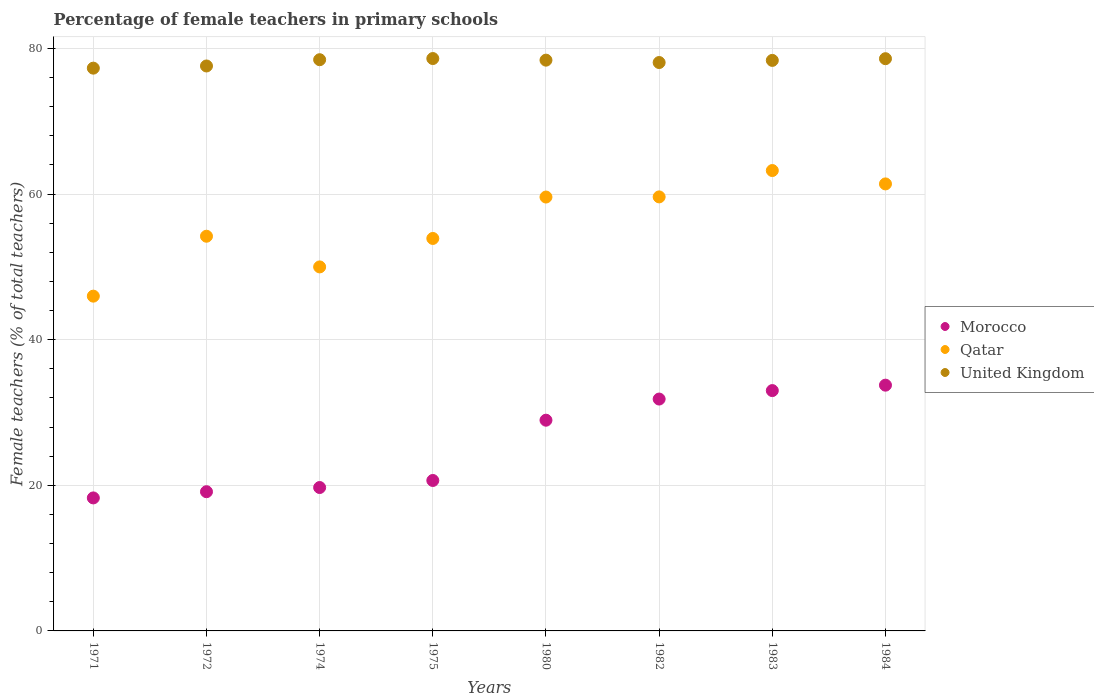How many different coloured dotlines are there?
Make the answer very short. 3. Is the number of dotlines equal to the number of legend labels?
Your answer should be compact. Yes. What is the percentage of female teachers in Qatar in 1984?
Your answer should be compact. 61.4. Across all years, what is the maximum percentage of female teachers in Morocco?
Offer a very short reply. 33.76. Across all years, what is the minimum percentage of female teachers in Morocco?
Ensure brevity in your answer.  18.27. In which year was the percentage of female teachers in Morocco maximum?
Offer a terse response. 1984. What is the total percentage of female teachers in Qatar in the graph?
Give a very brief answer. 447.96. What is the difference between the percentage of female teachers in Qatar in 1975 and that in 1984?
Provide a succinct answer. -7.49. What is the difference between the percentage of female teachers in Morocco in 1984 and the percentage of female teachers in Qatar in 1982?
Provide a succinct answer. -25.86. What is the average percentage of female teachers in Qatar per year?
Give a very brief answer. 56. In the year 1972, what is the difference between the percentage of female teachers in Qatar and percentage of female teachers in Morocco?
Your answer should be very brief. 35.09. What is the ratio of the percentage of female teachers in Qatar in 1974 to that in 1984?
Make the answer very short. 0.81. Is the percentage of female teachers in Qatar in 1975 less than that in 1984?
Make the answer very short. Yes. Is the difference between the percentage of female teachers in Qatar in 1971 and 1982 greater than the difference between the percentage of female teachers in Morocco in 1971 and 1982?
Your answer should be very brief. No. What is the difference between the highest and the second highest percentage of female teachers in Qatar?
Offer a very short reply. 1.84. What is the difference between the highest and the lowest percentage of female teachers in Morocco?
Make the answer very short. 15.49. Is it the case that in every year, the sum of the percentage of female teachers in Qatar and percentage of female teachers in United Kingdom  is greater than the percentage of female teachers in Morocco?
Your answer should be very brief. Yes. Is the percentage of female teachers in Qatar strictly greater than the percentage of female teachers in Morocco over the years?
Your answer should be compact. Yes. How many dotlines are there?
Provide a succinct answer. 3. What is the difference between two consecutive major ticks on the Y-axis?
Make the answer very short. 20. How many legend labels are there?
Provide a succinct answer. 3. How are the legend labels stacked?
Offer a terse response. Vertical. What is the title of the graph?
Make the answer very short. Percentage of female teachers in primary schools. Does "Tunisia" appear as one of the legend labels in the graph?
Keep it short and to the point. No. What is the label or title of the Y-axis?
Offer a very short reply. Female teachers (% of total teachers). What is the Female teachers (% of total teachers) in Morocco in 1971?
Ensure brevity in your answer.  18.27. What is the Female teachers (% of total teachers) in Qatar in 1971?
Provide a short and direct response. 45.98. What is the Female teachers (% of total teachers) of United Kingdom in 1971?
Provide a succinct answer. 77.3. What is the Female teachers (% of total teachers) of Morocco in 1972?
Your answer should be compact. 19.12. What is the Female teachers (% of total teachers) of Qatar in 1972?
Make the answer very short. 54.21. What is the Female teachers (% of total teachers) of United Kingdom in 1972?
Keep it short and to the point. 77.6. What is the Female teachers (% of total teachers) of Morocco in 1974?
Offer a very short reply. 19.7. What is the Female teachers (% of total teachers) in Qatar in 1974?
Your answer should be compact. 50. What is the Female teachers (% of total teachers) of United Kingdom in 1974?
Provide a succinct answer. 78.46. What is the Female teachers (% of total teachers) of Morocco in 1975?
Offer a very short reply. 20.66. What is the Female teachers (% of total teachers) of Qatar in 1975?
Provide a succinct answer. 53.91. What is the Female teachers (% of total teachers) in United Kingdom in 1975?
Provide a short and direct response. 78.62. What is the Female teachers (% of total teachers) in Morocco in 1980?
Give a very brief answer. 28.95. What is the Female teachers (% of total teachers) in Qatar in 1980?
Provide a succinct answer. 59.6. What is the Female teachers (% of total teachers) of United Kingdom in 1980?
Ensure brevity in your answer.  78.4. What is the Female teachers (% of total teachers) in Morocco in 1982?
Your response must be concise. 31.85. What is the Female teachers (% of total teachers) in Qatar in 1982?
Your response must be concise. 59.62. What is the Female teachers (% of total teachers) of United Kingdom in 1982?
Ensure brevity in your answer.  78.07. What is the Female teachers (% of total teachers) in Morocco in 1983?
Your answer should be compact. 33.01. What is the Female teachers (% of total teachers) in Qatar in 1983?
Your answer should be very brief. 63.24. What is the Female teachers (% of total teachers) of United Kingdom in 1983?
Offer a very short reply. 78.37. What is the Female teachers (% of total teachers) in Morocco in 1984?
Your answer should be very brief. 33.76. What is the Female teachers (% of total teachers) of Qatar in 1984?
Ensure brevity in your answer.  61.4. What is the Female teachers (% of total teachers) in United Kingdom in 1984?
Provide a short and direct response. 78.6. Across all years, what is the maximum Female teachers (% of total teachers) in Morocco?
Provide a succinct answer. 33.76. Across all years, what is the maximum Female teachers (% of total teachers) of Qatar?
Offer a terse response. 63.24. Across all years, what is the maximum Female teachers (% of total teachers) in United Kingdom?
Your answer should be compact. 78.62. Across all years, what is the minimum Female teachers (% of total teachers) in Morocco?
Your answer should be compact. 18.27. Across all years, what is the minimum Female teachers (% of total teachers) of Qatar?
Give a very brief answer. 45.98. Across all years, what is the minimum Female teachers (% of total teachers) in United Kingdom?
Offer a terse response. 77.3. What is the total Female teachers (% of total teachers) in Morocco in the graph?
Offer a very short reply. 205.31. What is the total Female teachers (% of total teachers) of Qatar in the graph?
Your answer should be compact. 447.96. What is the total Female teachers (% of total teachers) of United Kingdom in the graph?
Keep it short and to the point. 625.43. What is the difference between the Female teachers (% of total teachers) of Morocco in 1971 and that in 1972?
Give a very brief answer. -0.85. What is the difference between the Female teachers (% of total teachers) of Qatar in 1971 and that in 1972?
Your answer should be very brief. -8.23. What is the difference between the Female teachers (% of total teachers) in United Kingdom in 1971 and that in 1972?
Offer a very short reply. -0.3. What is the difference between the Female teachers (% of total teachers) of Morocco in 1971 and that in 1974?
Provide a short and direct response. -1.43. What is the difference between the Female teachers (% of total teachers) in Qatar in 1971 and that in 1974?
Ensure brevity in your answer.  -4.02. What is the difference between the Female teachers (% of total teachers) in United Kingdom in 1971 and that in 1974?
Provide a succinct answer. -1.16. What is the difference between the Female teachers (% of total teachers) of Morocco in 1971 and that in 1975?
Make the answer very short. -2.4. What is the difference between the Female teachers (% of total teachers) of Qatar in 1971 and that in 1975?
Give a very brief answer. -7.92. What is the difference between the Female teachers (% of total teachers) of United Kingdom in 1971 and that in 1975?
Your response must be concise. -1.32. What is the difference between the Female teachers (% of total teachers) of Morocco in 1971 and that in 1980?
Make the answer very short. -10.68. What is the difference between the Female teachers (% of total teachers) of Qatar in 1971 and that in 1980?
Offer a very short reply. -13.61. What is the difference between the Female teachers (% of total teachers) in United Kingdom in 1971 and that in 1980?
Your response must be concise. -1.1. What is the difference between the Female teachers (% of total teachers) of Morocco in 1971 and that in 1982?
Offer a very short reply. -13.58. What is the difference between the Female teachers (% of total teachers) of Qatar in 1971 and that in 1982?
Your answer should be compact. -13.63. What is the difference between the Female teachers (% of total teachers) of United Kingdom in 1971 and that in 1982?
Keep it short and to the point. -0.77. What is the difference between the Female teachers (% of total teachers) in Morocco in 1971 and that in 1983?
Your answer should be compact. -14.74. What is the difference between the Female teachers (% of total teachers) in Qatar in 1971 and that in 1983?
Give a very brief answer. -17.25. What is the difference between the Female teachers (% of total teachers) of United Kingdom in 1971 and that in 1983?
Give a very brief answer. -1.07. What is the difference between the Female teachers (% of total teachers) of Morocco in 1971 and that in 1984?
Provide a short and direct response. -15.49. What is the difference between the Female teachers (% of total teachers) of Qatar in 1971 and that in 1984?
Your response must be concise. -15.42. What is the difference between the Female teachers (% of total teachers) in United Kingdom in 1971 and that in 1984?
Your response must be concise. -1.3. What is the difference between the Female teachers (% of total teachers) in Morocco in 1972 and that in 1974?
Your answer should be very brief. -0.58. What is the difference between the Female teachers (% of total teachers) of Qatar in 1972 and that in 1974?
Make the answer very short. 4.21. What is the difference between the Female teachers (% of total teachers) of United Kingdom in 1972 and that in 1974?
Offer a very short reply. -0.86. What is the difference between the Female teachers (% of total teachers) of Morocco in 1972 and that in 1975?
Your answer should be very brief. -1.54. What is the difference between the Female teachers (% of total teachers) of Qatar in 1972 and that in 1975?
Your answer should be very brief. 0.3. What is the difference between the Female teachers (% of total teachers) in United Kingdom in 1972 and that in 1975?
Make the answer very short. -1.02. What is the difference between the Female teachers (% of total teachers) of Morocco in 1972 and that in 1980?
Make the answer very short. -9.82. What is the difference between the Female teachers (% of total teachers) in Qatar in 1972 and that in 1980?
Keep it short and to the point. -5.38. What is the difference between the Female teachers (% of total teachers) of United Kingdom in 1972 and that in 1980?
Ensure brevity in your answer.  -0.8. What is the difference between the Female teachers (% of total teachers) of Morocco in 1972 and that in 1982?
Offer a very short reply. -12.73. What is the difference between the Female teachers (% of total teachers) of Qatar in 1972 and that in 1982?
Give a very brief answer. -5.4. What is the difference between the Female teachers (% of total teachers) in United Kingdom in 1972 and that in 1982?
Give a very brief answer. -0.47. What is the difference between the Female teachers (% of total teachers) in Morocco in 1972 and that in 1983?
Ensure brevity in your answer.  -13.89. What is the difference between the Female teachers (% of total teachers) of Qatar in 1972 and that in 1983?
Provide a short and direct response. -9.02. What is the difference between the Female teachers (% of total teachers) of United Kingdom in 1972 and that in 1983?
Your answer should be very brief. -0.77. What is the difference between the Female teachers (% of total teachers) of Morocco in 1972 and that in 1984?
Ensure brevity in your answer.  -14.64. What is the difference between the Female teachers (% of total teachers) of Qatar in 1972 and that in 1984?
Offer a very short reply. -7.19. What is the difference between the Female teachers (% of total teachers) in United Kingdom in 1972 and that in 1984?
Provide a short and direct response. -1. What is the difference between the Female teachers (% of total teachers) in Morocco in 1974 and that in 1975?
Your response must be concise. -0.97. What is the difference between the Female teachers (% of total teachers) in Qatar in 1974 and that in 1975?
Offer a terse response. -3.91. What is the difference between the Female teachers (% of total teachers) in United Kingdom in 1974 and that in 1975?
Your answer should be very brief. -0.16. What is the difference between the Female teachers (% of total teachers) of Morocco in 1974 and that in 1980?
Offer a very short reply. -9.25. What is the difference between the Female teachers (% of total teachers) of Qatar in 1974 and that in 1980?
Provide a succinct answer. -9.6. What is the difference between the Female teachers (% of total teachers) of United Kingdom in 1974 and that in 1980?
Your answer should be compact. 0.06. What is the difference between the Female teachers (% of total teachers) in Morocco in 1974 and that in 1982?
Provide a short and direct response. -12.15. What is the difference between the Female teachers (% of total teachers) of Qatar in 1974 and that in 1982?
Offer a very short reply. -9.62. What is the difference between the Female teachers (% of total teachers) of United Kingdom in 1974 and that in 1982?
Offer a very short reply. 0.39. What is the difference between the Female teachers (% of total teachers) in Morocco in 1974 and that in 1983?
Offer a very short reply. -13.31. What is the difference between the Female teachers (% of total teachers) of Qatar in 1974 and that in 1983?
Offer a terse response. -13.24. What is the difference between the Female teachers (% of total teachers) of United Kingdom in 1974 and that in 1983?
Your answer should be very brief. 0.09. What is the difference between the Female teachers (% of total teachers) of Morocco in 1974 and that in 1984?
Offer a terse response. -14.06. What is the difference between the Female teachers (% of total teachers) of Qatar in 1974 and that in 1984?
Ensure brevity in your answer.  -11.4. What is the difference between the Female teachers (% of total teachers) of United Kingdom in 1974 and that in 1984?
Offer a very short reply. -0.14. What is the difference between the Female teachers (% of total teachers) of Morocco in 1975 and that in 1980?
Provide a short and direct response. -8.28. What is the difference between the Female teachers (% of total teachers) of Qatar in 1975 and that in 1980?
Offer a terse response. -5.69. What is the difference between the Female teachers (% of total teachers) of United Kingdom in 1975 and that in 1980?
Keep it short and to the point. 0.22. What is the difference between the Female teachers (% of total teachers) of Morocco in 1975 and that in 1982?
Keep it short and to the point. -11.18. What is the difference between the Female teachers (% of total teachers) of Qatar in 1975 and that in 1982?
Provide a short and direct response. -5.71. What is the difference between the Female teachers (% of total teachers) of United Kingdom in 1975 and that in 1982?
Your response must be concise. 0.55. What is the difference between the Female teachers (% of total teachers) of Morocco in 1975 and that in 1983?
Ensure brevity in your answer.  -12.35. What is the difference between the Female teachers (% of total teachers) in Qatar in 1975 and that in 1983?
Offer a very short reply. -9.33. What is the difference between the Female teachers (% of total teachers) in United Kingdom in 1975 and that in 1983?
Your answer should be compact. 0.25. What is the difference between the Female teachers (% of total teachers) of Morocco in 1975 and that in 1984?
Make the answer very short. -13.09. What is the difference between the Female teachers (% of total teachers) in Qatar in 1975 and that in 1984?
Offer a terse response. -7.49. What is the difference between the Female teachers (% of total teachers) in United Kingdom in 1975 and that in 1984?
Provide a succinct answer. 0.02. What is the difference between the Female teachers (% of total teachers) of Morocco in 1980 and that in 1982?
Make the answer very short. -2.9. What is the difference between the Female teachers (% of total teachers) of Qatar in 1980 and that in 1982?
Give a very brief answer. -0.02. What is the difference between the Female teachers (% of total teachers) in United Kingdom in 1980 and that in 1982?
Provide a succinct answer. 0.33. What is the difference between the Female teachers (% of total teachers) of Morocco in 1980 and that in 1983?
Offer a very short reply. -4.07. What is the difference between the Female teachers (% of total teachers) of Qatar in 1980 and that in 1983?
Provide a short and direct response. -3.64. What is the difference between the Female teachers (% of total teachers) in United Kingdom in 1980 and that in 1983?
Your response must be concise. 0.03. What is the difference between the Female teachers (% of total teachers) of Morocco in 1980 and that in 1984?
Provide a succinct answer. -4.81. What is the difference between the Female teachers (% of total teachers) in Qatar in 1980 and that in 1984?
Make the answer very short. -1.8. What is the difference between the Female teachers (% of total teachers) of United Kingdom in 1980 and that in 1984?
Ensure brevity in your answer.  -0.2. What is the difference between the Female teachers (% of total teachers) in Morocco in 1982 and that in 1983?
Make the answer very short. -1.16. What is the difference between the Female teachers (% of total teachers) in Qatar in 1982 and that in 1983?
Offer a terse response. -3.62. What is the difference between the Female teachers (% of total teachers) in United Kingdom in 1982 and that in 1983?
Your answer should be compact. -0.29. What is the difference between the Female teachers (% of total teachers) in Morocco in 1982 and that in 1984?
Your response must be concise. -1.91. What is the difference between the Female teachers (% of total teachers) of Qatar in 1982 and that in 1984?
Give a very brief answer. -1.78. What is the difference between the Female teachers (% of total teachers) in United Kingdom in 1982 and that in 1984?
Give a very brief answer. -0.53. What is the difference between the Female teachers (% of total teachers) in Morocco in 1983 and that in 1984?
Ensure brevity in your answer.  -0.74. What is the difference between the Female teachers (% of total teachers) of Qatar in 1983 and that in 1984?
Offer a very short reply. 1.84. What is the difference between the Female teachers (% of total teachers) in United Kingdom in 1983 and that in 1984?
Provide a succinct answer. -0.23. What is the difference between the Female teachers (% of total teachers) of Morocco in 1971 and the Female teachers (% of total teachers) of Qatar in 1972?
Keep it short and to the point. -35.95. What is the difference between the Female teachers (% of total teachers) in Morocco in 1971 and the Female teachers (% of total teachers) in United Kingdom in 1972?
Your answer should be compact. -59.33. What is the difference between the Female teachers (% of total teachers) in Qatar in 1971 and the Female teachers (% of total teachers) in United Kingdom in 1972?
Offer a terse response. -31.62. What is the difference between the Female teachers (% of total teachers) of Morocco in 1971 and the Female teachers (% of total teachers) of Qatar in 1974?
Provide a succinct answer. -31.73. What is the difference between the Female teachers (% of total teachers) of Morocco in 1971 and the Female teachers (% of total teachers) of United Kingdom in 1974?
Your response must be concise. -60.19. What is the difference between the Female teachers (% of total teachers) of Qatar in 1971 and the Female teachers (% of total teachers) of United Kingdom in 1974?
Keep it short and to the point. -32.48. What is the difference between the Female teachers (% of total teachers) of Morocco in 1971 and the Female teachers (% of total teachers) of Qatar in 1975?
Keep it short and to the point. -35.64. What is the difference between the Female teachers (% of total teachers) in Morocco in 1971 and the Female teachers (% of total teachers) in United Kingdom in 1975?
Offer a very short reply. -60.35. What is the difference between the Female teachers (% of total teachers) in Qatar in 1971 and the Female teachers (% of total teachers) in United Kingdom in 1975?
Provide a succinct answer. -32.64. What is the difference between the Female teachers (% of total teachers) of Morocco in 1971 and the Female teachers (% of total teachers) of Qatar in 1980?
Offer a very short reply. -41.33. What is the difference between the Female teachers (% of total teachers) in Morocco in 1971 and the Female teachers (% of total teachers) in United Kingdom in 1980?
Provide a short and direct response. -60.13. What is the difference between the Female teachers (% of total teachers) in Qatar in 1971 and the Female teachers (% of total teachers) in United Kingdom in 1980?
Your answer should be very brief. -32.42. What is the difference between the Female teachers (% of total teachers) in Morocco in 1971 and the Female teachers (% of total teachers) in Qatar in 1982?
Provide a succinct answer. -41.35. What is the difference between the Female teachers (% of total teachers) of Morocco in 1971 and the Female teachers (% of total teachers) of United Kingdom in 1982?
Ensure brevity in your answer.  -59.81. What is the difference between the Female teachers (% of total teachers) of Qatar in 1971 and the Female teachers (% of total teachers) of United Kingdom in 1982?
Ensure brevity in your answer.  -32.09. What is the difference between the Female teachers (% of total teachers) of Morocco in 1971 and the Female teachers (% of total teachers) of Qatar in 1983?
Your response must be concise. -44.97. What is the difference between the Female teachers (% of total teachers) in Morocco in 1971 and the Female teachers (% of total teachers) in United Kingdom in 1983?
Your answer should be compact. -60.1. What is the difference between the Female teachers (% of total teachers) of Qatar in 1971 and the Female teachers (% of total teachers) of United Kingdom in 1983?
Offer a very short reply. -32.38. What is the difference between the Female teachers (% of total teachers) of Morocco in 1971 and the Female teachers (% of total teachers) of Qatar in 1984?
Make the answer very short. -43.13. What is the difference between the Female teachers (% of total teachers) in Morocco in 1971 and the Female teachers (% of total teachers) in United Kingdom in 1984?
Your response must be concise. -60.33. What is the difference between the Female teachers (% of total teachers) of Qatar in 1971 and the Female teachers (% of total teachers) of United Kingdom in 1984?
Provide a succinct answer. -32.62. What is the difference between the Female teachers (% of total teachers) in Morocco in 1972 and the Female teachers (% of total teachers) in Qatar in 1974?
Your answer should be very brief. -30.88. What is the difference between the Female teachers (% of total teachers) of Morocco in 1972 and the Female teachers (% of total teachers) of United Kingdom in 1974?
Offer a very short reply. -59.34. What is the difference between the Female teachers (% of total teachers) of Qatar in 1972 and the Female teachers (% of total teachers) of United Kingdom in 1974?
Provide a short and direct response. -24.25. What is the difference between the Female teachers (% of total teachers) in Morocco in 1972 and the Female teachers (% of total teachers) in Qatar in 1975?
Make the answer very short. -34.79. What is the difference between the Female teachers (% of total teachers) in Morocco in 1972 and the Female teachers (% of total teachers) in United Kingdom in 1975?
Give a very brief answer. -59.5. What is the difference between the Female teachers (% of total teachers) in Qatar in 1972 and the Female teachers (% of total teachers) in United Kingdom in 1975?
Offer a very short reply. -24.41. What is the difference between the Female teachers (% of total teachers) in Morocco in 1972 and the Female teachers (% of total teachers) in Qatar in 1980?
Your answer should be very brief. -40.48. What is the difference between the Female teachers (% of total teachers) of Morocco in 1972 and the Female teachers (% of total teachers) of United Kingdom in 1980?
Provide a short and direct response. -59.28. What is the difference between the Female teachers (% of total teachers) in Qatar in 1972 and the Female teachers (% of total teachers) in United Kingdom in 1980?
Make the answer very short. -24.19. What is the difference between the Female teachers (% of total teachers) of Morocco in 1972 and the Female teachers (% of total teachers) of Qatar in 1982?
Keep it short and to the point. -40.5. What is the difference between the Female teachers (% of total teachers) of Morocco in 1972 and the Female teachers (% of total teachers) of United Kingdom in 1982?
Make the answer very short. -58.95. What is the difference between the Female teachers (% of total teachers) in Qatar in 1972 and the Female teachers (% of total teachers) in United Kingdom in 1982?
Make the answer very short. -23.86. What is the difference between the Female teachers (% of total teachers) in Morocco in 1972 and the Female teachers (% of total teachers) in Qatar in 1983?
Your answer should be very brief. -44.12. What is the difference between the Female teachers (% of total teachers) of Morocco in 1972 and the Female teachers (% of total teachers) of United Kingdom in 1983?
Your answer should be very brief. -59.25. What is the difference between the Female teachers (% of total teachers) in Qatar in 1972 and the Female teachers (% of total teachers) in United Kingdom in 1983?
Your response must be concise. -24.15. What is the difference between the Female teachers (% of total teachers) in Morocco in 1972 and the Female teachers (% of total teachers) in Qatar in 1984?
Your answer should be very brief. -42.28. What is the difference between the Female teachers (% of total teachers) of Morocco in 1972 and the Female teachers (% of total teachers) of United Kingdom in 1984?
Offer a very short reply. -59.48. What is the difference between the Female teachers (% of total teachers) of Qatar in 1972 and the Female teachers (% of total teachers) of United Kingdom in 1984?
Provide a short and direct response. -24.39. What is the difference between the Female teachers (% of total teachers) in Morocco in 1974 and the Female teachers (% of total teachers) in Qatar in 1975?
Your answer should be very brief. -34.21. What is the difference between the Female teachers (% of total teachers) of Morocco in 1974 and the Female teachers (% of total teachers) of United Kingdom in 1975?
Keep it short and to the point. -58.92. What is the difference between the Female teachers (% of total teachers) of Qatar in 1974 and the Female teachers (% of total teachers) of United Kingdom in 1975?
Offer a very short reply. -28.62. What is the difference between the Female teachers (% of total teachers) of Morocco in 1974 and the Female teachers (% of total teachers) of Qatar in 1980?
Your answer should be compact. -39.9. What is the difference between the Female teachers (% of total teachers) of Morocco in 1974 and the Female teachers (% of total teachers) of United Kingdom in 1980?
Your answer should be very brief. -58.7. What is the difference between the Female teachers (% of total teachers) of Qatar in 1974 and the Female teachers (% of total teachers) of United Kingdom in 1980?
Give a very brief answer. -28.4. What is the difference between the Female teachers (% of total teachers) of Morocco in 1974 and the Female teachers (% of total teachers) of Qatar in 1982?
Keep it short and to the point. -39.92. What is the difference between the Female teachers (% of total teachers) of Morocco in 1974 and the Female teachers (% of total teachers) of United Kingdom in 1982?
Offer a terse response. -58.38. What is the difference between the Female teachers (% of total teachers) in Qatar in 1974 and the Female teachers (% of total teachers) in United Kingdom in 1982?
Provide a succinct answer. -28.07. What is the difference between the Female teachers (% of total teachers) of Morocco in 1974 and the Female teachers (% of total teachers) of Qatar in 1983?
Your answer should be very brief. -43.54. What is the difference between the Female teachers (% of total teachers) in Morocco in 1974 and the Female teachers (% of total teachers) in United Kingdom in 1983?
Make the answer very short. -58.67. What is the difference between the Female teachers (% of total teachers) of Qatar in 1974 and the Female teachers (% of total teachers) of United Kingdom in 1983?
Keep it short and to the point. -28.37. What is the difference between the Female teachers (% of total teachers) of Morocco in 1974 and the Female teachers (% of total teachers) of Qatar in 1984?
Keep it short and to the point. -41.7. What is the difference between the Female teachers (% of total teachers) of Morocco in 1974 and the Female teachers (% of total teachers) of United Kingdom in 1984?
Give a very brief answer. -58.9. What is the difference between the Female teachers (% of total teachers) in Qatar in 1974 and the Female teachers (% of total teachers) in United Kingdom in 1984?
Provide a short and direct response. -28.6. What is the difference between the Female teachers (% of total teachers) in Morocco in 1975 and the Female teachers (% of total teachers) in Qatar in 1980?
Provide a succinct answer. -38.93. What is the difference between the Female teachers (% of total teachers) of Morocco in 1975 and the Female teachers (% of total teachers) of United Kingdom in 1980?
Your response must be concise. -57.74. What is the difference between the Female teachers (% of total teachers) of Qatar in 1975 and the Female teachers (% of total teachers) of United Kingdom in 1980?
Provide a short and direct response. -24.49. What is the difference between the Female teachers (% of total teachers) in Morocco in 1975 and the Female teachers (% of total teachers) in Qatar in 1982?
Keep it short and to the point. -38.95. What is the difference between the Female teachers (% of total teachers) in Morocco in 1975 and the Female teachers (% of total teachers) in United Kingdom in 1982?
Your response must be concise. -57.41. What is the difference between the Female teachers (% of total teachers) in Qatar in 1975 and the Female teachers (% of total teachers) in United Kingdom in 1982?
Ensure brevity in your answer.  -24.17. What is the difference between the Female teachers (% of total teachers) of Morocco in 1975 and the Female teachers (% of total teachers) of Qatar in 1983?
Give a very brief answer. -42.57. What is the difference between the Female teachers (% of total teachers) of Morocco in 1975 and the Female teachers (% of total teachers) of United Kingdom in 1983?
Ensure brevity in your answer.  -57.7. What is the difference between the Female teachers (% of total teachers) of Qatar in 1975 and the Female teachers (% of total teachers) of United Kingdom in 1983?
Provide a succinct answer. -24.46. What is the difference between the Female teachers (% of total teachers) of Morocco in 1975 and the Female teachers (% of total teachers) of Qatar in 1984?
Provide a short and direct response. -40.74. What is the difference between the Female teachers (% of total teachers) of Morocco in 1975 and the Female teachers (% of total teachers) of United Kingdom in 1984?
Ensure brevity in your answer.  -57.94. What is the difference between the Female teachers (% of total teachers) in Qatar in 1975 and the Female teachers (% of total teachers) in United Kingdom in 1984?
Your response must be concise. -24.69. What is the difference between the Female teachers (% of total teachers) of Morocco in 1980 and the Female teachers (% of total teachers) of Qatar in 1982?
Give a very brief answer. -30.67. What is the difference between the Female teachers (% of total teachers) of Morocco in 1980 and the Female teachers (% of total teachers) of United Kingdom in 1982?
Your answer should be very brief. -49.13. What is the difference between the Female teachers (% of total teachers) in Qatar in 1980 and the Female teachers (% of total teachers) in United Kingdom in 1982?
Ensure brevity in your answer.  -18.48. What is the difference between the Female teachers (% of total teachers) of Morocco in 1980 and the Female teachers (% of total teachers) of Qatar in 1983?
Offer a terse response. -34.29. What is the difference between the Female teachers (% of total teachers) of Morocco in 1980 and the Female teachers (% of total teachers) of United Kingdom in 1983?
Provide a short and direct response. -49.42. What is the difference between the Female teachers (% of total teachers) in Qatar in 1980 and the Female teachers (% of total teachers) in United Kingdom in 1983?
Offer a terse response. -18.77. What is the difference between the Female teachers (% of total teachers) in Morocco in 1980 and the Female teachers (% of total teachers) in Qatar in 1984?
Provide a short and direct response. -32.46. What is the difference between the Female teachers (% of total teachers) of Morocco in 1980 and the Female teachers (% of total teachers) of United Kingdom in 1984?
Offer a terse response. -49.66. What is the difference between the Female teachers (% of total teachers) of Qatar in 1980 and the Female teachers (% of total teachers) of United Kingdom in 1984?
Your answer should be very brief. -19. What is the difference between the Female teachers (% of total teachers) in Morocco in 1982 and the Female teachers (% of total teachers) in Qatar in 1983?
Keep it short and to the point. -31.39. What is the difference between the Female teachers (% of total teachers) in Morocco in 1982 and the Female teachers (% of total teachers) in United Kingdom in 1983?
Ensure brevity in your answer.  -46.52. What is the difference between the Female teachers (% of total teachers) of Qatar in 1982 and the Female teachers (% of total teachers) of United Kingdom in 1983?
Your response must be concise. -18.75. What is the difference between the Female teachers (% of total teachers) of Morocco in 1982 and the Female teachers (% of total teachers) of Qatar in 1984?
Your answer should be compact. -29.55. What is the difference between the Female teachers (% of total teachers) of Morocco in 1982 and the Female teachers (% of total teachers) of United Kingdom in 1984?
Offer a terse response. -46.75. What is the difference between the Female teachers (% of total teachers) of Qatar in 1982 and the Female teachers (% of total teachers) of United Kingdom in 1984?
Provide a short and direct response. -18.98. What is the difference between the Female teachers (% of total teachers) in Morocco in 1983 and the Female teachers (% of total teachers) in Qatar in 1984?
Keep it short and to the point. -28.39. What is the difference between the Female teachers (% of total teachers) in Morocco in 1983 and the Female teachers (% of total teachers) in United Kingdom in 1984?
Your answer should be compact. -45.59. What is the difference between the Female teachers (% of total teachers) in Qatar in 1983 and the Female teachers (% of total teachers) in United Kingdom in 1984?
Keep it short and to the point. -15.36. What is the average Female teachers (% of total teachers) in Morocco per year?
Keep it short and to the point. 25.66. What is the average Female teachers (% of total teachers) in Qatar per year?
Keep it short and to the point. 56. What is the average Female teachers (% of total teachers) in United Kingdom per year?
Provide a succinct answer. 78.18. In the year 1971, what is the difference between the Female teachers (% of total teachers) in Morocco and Female teachers (% of total teachers) in Qatar?
Your answer should be very brief. -27.72. In the year 1971, what is the difference between the Female teachers (% of total teachers) of Morocco and Female teachers (% of total teachers) of United Kingdom?
Provide a succinct answer. -59.03. In the year 1971, what is the difference between the Female teachers (% of total teachers) in Qatar and Female teachers (% of total teachers) in United Kingdom?
Offer a very short reply. -31.32. In the year 1972, what is the difference between the Female teachers (% of total teachers) in Morocco and Female teachers (% of total teachers) in Qatar?
Give a very brief answer. -35.09. In the year 1972, what is the difference between the Female teachers (% of total teachers) in Morocco and Female teachers (% of total teachers) in United Kingdom?
Provide a short and direct response. -58.48. In the year 1972, what is the difference between the Female teachers (% of total teachers) of Qatar and Female teachers (% of total teachers) of United Kingdom?
Your answer should be compact. -23.39. In the year 1974, what is the difference between the Female teachers (% of total teachers) in Morocco and Female teachers (% of total teachers) in Qatar?
Offer a very short reply. -30.3. In the year 1974, what is the difference between the Female teachers (% of total teachers) in Morocco and Female teachers (% of total teachers) in United Kingdom?
Your answer should be very brief. -58.76. In the year 1974, what is the difference between the Female teachers (% of total teachers) of Qatar and Female teachers (% of total teachers) of United Kingdom?
Your answer should be compact. -28.46. In the year 1975, what is the difference between the Female teachers (% of total teachers) of Morocco and Female teachers (% of total teachers) of Qatar?
Offer a very short reply. -33.24. In the year 1975, what is the difference between the Female teachers (% of total teachers) in Morocco and Female teachers (% of total teachers) in United Kingdom?
Your answer should be very brief. -57.96. In the year 1975, what is the difference between the Female teachers (% of total teachers) in Qatar and Female teachers (% of total teachers) in United Kingdom?
Offer a terse response. -24.71. In the year 1980, what is the difference between the Female teachers (% of total teachers) of Morocco and Female teachers (% of total teachers) of Qatar?
Your answer should be compact. -30.65. In the year 1980, what is the difference between the Female teachers (% of total teachers) of Morocco and Female teachers (% of total teachers) of United Kingdom?
Provide a short and direct response. -49.46. In the year 1980, what is the difference between the Female teachers (% of total teachers) of Qatar and Female teachers (% of total teachers) of United Kingdom?
Give a very brief answer. -18.8. In the year 1982, what is the difference between the Female teachers (% of total teachers) of Morocco and Female teachers (% of total teachers) of Qatar?
Make the answer very short. -27.77. In the year 1982, what is the difference between the Female teachers (% of total teachers) in Morocco and Female teachers (% of total teachers) in United Kingdom?
Provide a succinct answer. -46.23. In the year 1982, what is the difference between the Female teachers (% of total teachers) of Qatar and Female teachers (% of total teachers) of United Kingdom?
Offer a terse response. -18.46. In the year 1983, what is the difference between the Female teachers (% of total teachers) in Morocco and Female teachers (% of total teachers) in Qatar?
Your answer should be very brief. -30.23. In the year 1983, what is the difference between the Female teachers (% of total teachers) in Morocco and Female teachers (% of total teachers) in United Kingdom?
Provide a succinct answer. -45.36. In the year 1983, what is the difference between the Female teachers (% of total teachers) of Qatar and Female teachers (% of total teachers) of United Kingdom?
Offer a terse response. -15.13. In the year 1984, what is the difference between the Female teachers (% of total teachers) in Morocco and Female teachers (% of total teachers) in Qatar?
Give a very brief answer. -27.64. In the year 1984, what is the difference between the Female teachers (% of total teachers) of Morocco and Female teachers (% of total teachers) of United Kingdom?
Your response must be concise. -44.84. In the year 1984, what is the difference between the Female teachers (% of total teachers) in Qatar and Female teachers (% of total teachers) in United Kingdom?
Your response must be concise. -17.2. What is the ratio of the Female teachers (% of total teachers) of Morocco in 1971 to that in 1972?
Provide a short and direct response. 0.96. What is the ratio of the Female teachers (% of total teachers) in Qatar in 1971 to that in 1972?
Give a very brief answer. 0.85. What is the ratio of the Female teachers (% of total teachers) in Morocco in 1971 to that in 1974?
Your answer should be very brief. 0.93. What is the ratio of the Female teachers (% of total teachers) in Qatar in 1971 to that in 1974?
Provide a succinct answer. 0.92. What is the ratio of the Female teachers (% of total teachers) in United Kingdom in 1971 to that in 1974?
Offer a terse response. 0.99. What is the ratio of the Female teachers (% of total teachers) in Morocco in 1971 to that in 1975?
Your answer should be very brief. 0.88. What is the ratio of the Female teachers (% of total teachers) of Qatar in 1971 to that in 1975?
Provide a short and direct response. 0.85. What is the ratio of the Female teachers (% of total teachers) of United Kingdom in 1971 to that in 1975?
Keep it short and to the point. 0.98. What is the ratio of the Female teachers (% of total teachers) of Morocco in 1971 to that in 1980?
Make the answer very short. 0.63. What is the ratio of the Female teachers (% of total teachers) of Qatar in 1971 to that in 1980?
Offer a terse response. 0.77. What is the ratio of the Female teachers (% of total teachers) in Morocco in 1971 to that in 1982?
Your answer should be compact. 0.57. What is the ratio of the Female teachers (% of total teachers) in Qatar in 1971 to that in 1982?
Give a very brief answer. 0.77. What is the ratio of the Female teachers (% of total teachers) of United Kingdom in 1971 to that in 1982?
Keep it short and to the point. 0.99. What is the ratio of the Female teachers (% of total teachers) in Morocco in 1971 to that in 1983?
Keep it short and to the point. 0.55. What is the ratio of the Female teachers (% of total teachers) in Qatar in 1971 to that in 1983?
Offer a very short reply. 0.73. What is the ratio of the Female teachers (% of total teachers) of United Kingdom in 1971 to that in 1983?
Ensure brevity in your answer.  0.99. What is the ratio of the Female teachers (% of total teachers) in Morocco in 1971 to that in 1984?
Make the answer very short. 0.54. What is the ratio of the Female teachers (% of total teachers) in Qatar in 1971 to that in 1984?
Offer a very short reply. 0.75. What is the ratio of the Female teachers (% of total teachers) in United Kingdom in 1971 to that in 1984?
Provide a short and direct response. 0.98. What is the ratio of the Female teachers (% of total teachers) of Morocco in 1972 to that in 1974?
Keep it short and to the point. 0.97. What is the ratio of the Female teachers (% of total teachers) in Qatar in 1972 to that in 1974?
Provide a short and direct response. 1.08. What is the ratio of the Female teachers (% of total teachers) in United Kingdom in 1972 to that in 1974?
Your answer should be compact. 0.99. What is the ratio of the Female teachers (% of total teachers) in Morocco in 1972 to that in 1975?
Keep it short and to the point. 0.93. What is the ratio of the Female teachers (% of total teachers) of Qatar in 1972 to that in 1975?
Provide a short and direct response. 1.01. What is the ratio of the Female teachers (% of total teachers) in United Kingdom in 1972 to that in 1975?
Provide a short and direct response. 0.99. What is the ratio of the Female teachers (% of total teachers) of Morocco in 1972 to that in 1980?
Ensure brevity in your answer.  0.66. What is the ratio of the Female teachers (% of total teachers) of Qatar in 1972 to that in 1980?
Your answer should be very brief. 0.91. What is the ratio of the Female teachers (% of total teachers) in Morocco in 1972 to that in 1982?
Your response must be concise. 0.6. What is the ratio of the Female teachers (% of total teachers) in Qatar in 1972 to that in 1982?
Your response must be concise. 0.91. What is the ratio of the Female teachers (% of total teachers) of United Kingdom in 1972 to that in 1982?
Your response must be concise. 0.99. What is the ratio of the Female teachers (% of total teachers) in Morocco in 1972 to that in 1983?
Ensure brevity in your answer.  0.58. What is the ratio of the Female teachers (% of total teachers) of Qatar in 1972 to that in 1983?
Your response must be concise. 0.86. What is the ratio of the Female teachers (% of total teachers) of United Kingdom in 1972 to that in 1983?
Offer a very short reply. 0.99. What is the ratio of the Female teachers (% of total teachers) in Morocco in 1972 to that in 1984?
Your answer should be compact. 0.57. What is the ratio of the Female teachers (% of total teachers) in Qatar in 1972 to that in 1984?
Your answer should be compact. 0.88. What is the ratio of the Female teachers (% of total teachers) of United Kingdom in 1972 to that in 1984?
Provide a succinct answer. 0.99. What is the ratio of the Female teachers (% of total teachers) in Morocco in 1974 to that in 1975?
Keep it short and to the point. 0.95. What is the ratio of the Female teachers (% of total teachers) in Qatar in 1974 to that in 1975?
Make the answer very short. 0.93. What is the ratio of the Female teachers (% of total teachers) of United Kingdom in 1974 to that in 1975?
Provide a short and direct response. 1. What is the ratio of the Female teachers (% of total teachers) of Morocco in 1974 to that in 1980?
Give a very brief answer. 0.68. What is the ratio of the Female teachers (% of total teachers) of Qatar in 1974 to that in 1980?
Keep it short and to the point. 0.84. What is the ratio of the Female teachers (% of total teachers) of Morocco in 1974 to that in 1982?
Make the answer very short. 0.62. What is the ratio of the Female teachers (% of total teachers) in Qatar in 1974 to that in 1982?
Your answer should be compact. 0.84. What is the ratio of the Female teachers (% of total teachers) in Morocco in 1974 to that in 1983?
Ensure brevity in your answer.  0.6. What is the ratio of the Female teachers (% of total teachers) in Qatar in 1974 to that in 1983?
Offer a very short reply. 0.79. What is the ratio of the Female teachers (% of total teachers) of Morocco in 1974 to that in 1984?
Your answer should be compact. 0.58. What is the ratio of the Female teachers (% of total teachers) in Qatar in 1974 to that in 1984?
Keep it short and to the point. 0.81. What is the ratio of the Female teachers (% of total teachers) of United Kingdom in 1974 to that in 1984?
Provide a succinct answer. 1. What is the ratio of the Female teachers (% of total teachers) of Morocco in 1975 to that in 1980?
Ensure brevity in your answer.  0.71. What is the ratio of the Female teachers (% of total teachers) in Qatar in 1975 to that in 1980?
Provide a succinct answer. 0.9. What is the ratio of the Female teachers (% of total teachers) in Morocco in 1975 to that in 1982?
Your response must be concise. 0.65. What is the ratio of the Female teachers (% of total teachers) in Qatar in 1975 to that in 1982?
Keep it short and to the point. 0.9. What is the ratio of the Female teachers (% of total teachers) of Morocco in 1975 to that in 1983?
Your answer should be compact. 0.63. What is the ratio of the Female teachers (% of total teachers) of Qatar in 1975 to that in 1983?
Keep it short and to the point. 0.85. What is the ratio of the Female teachers (% of total teachers) of United Kingdom in 1975 to that in 1983?
Give a very brief answer. 1. What is the ratio of the Female teachers (% of total teachers) in Morocco in 1975 to that in 1984?
Keep it short and to the point. 0.61. What is the ratio of the Female teachers (% of total teachers) of Qatar in 1975 to that in 1984?
Provide a short and direct response. 0.88. What is the ratio of the Female teachers (% of total teachers) of Morocco in 1980 to that in 1982?
Offer a terse response. 0.91. What is the ratio of the Female teachers (% of total teachers) in Qatar in 1980 to that in 1982?
Your answer should be compact. 1. What is the ratio of the Female teachers (% of total teachers) of United Kingdom in 1980 to that in 1982?
Provide a short and direct response. 1. What is the ratio of the Female teachers (% of total teachers) of Morocco in 1980 to that in 1983?
Your response must be concise. 0.88. What is the ratio of the Female teachers (% of total teachers) in Qatar in 1980 to that in 1983?
Keep it short and to the point. 0.94. What is the ratio of the Female teachers (% of total teachers) in Morocco in 1980 to that in 1984?
Make the answer very short. 0.86. What is the ratio of the Female teachers (% of total teachers) of Qatar in 1980 to that in 1984?
Provide a succinct answer. 0.97. What is the ratio of the Female teachers (% of total teachers) of Morocco in 1982 to that in 1983?
Your answer should be compact. 0.96. What is the ratio of the Female teachers (% of total teachers) of Qatar in 1982 to that in 1983?
Offer a very short reply. 0.94. What is the ratio of the Female teachers (% of total teachers) of Morocco in 1982 to that in 1984?
Make the answer very short. 0.94. What is the ratio of the Female teachers (% of total teachers) of United Kingdom in 1982 to that in 1984?
Give a very brief answer. 0.99. What is the ratio of the Female teachers (% of total teachers) of Morocco in 1983 to that in 1984?
Offer a terse response. 0.98. What is the ratio of the Female teachers (% of total teachers) of Qatar in 1983 to that in 1984?
Your answer should be very brief. 1.03. What is the difference between the highest and the second highest Female teachers (% of total teachers) of Morocco?
Offer a very short reply. 0.74. What is the difference between the highest and the second highest Female teachers (% of total teachers) in Qatar?
Make the answer very short. 1.84. What is the difference between the highest and the second highest Female teachers (% of total teachers) in United Kingdom?
Ensure brevity in your answer.  0.02. What is the difference between the highest and the lowest Female teachers (% of total teachers) in Morocco?
Offer a very short reply. 15.49. What is the difference between the highest and the lowest Female teachers (% of total teachers) in Qatar?
Give a very brief answer. 17.25. What is the difference between the highest and the lowest Female teachers (% of total teachers) in United Kingdom?
Keep it short and to the point. 1.32. 